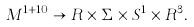<formula> <loc_0><loc_0><loc_500><loc_500>M ^ { 1 + 1 0 } \rightarrow R \times \Sigma \times S ^ { 1 } \times R ^ { 3 } .</formula> 